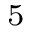Convert formula to latex. <formula><loc_0><loc_0><loc_500><loc_500>_ { 5 }</formula> 